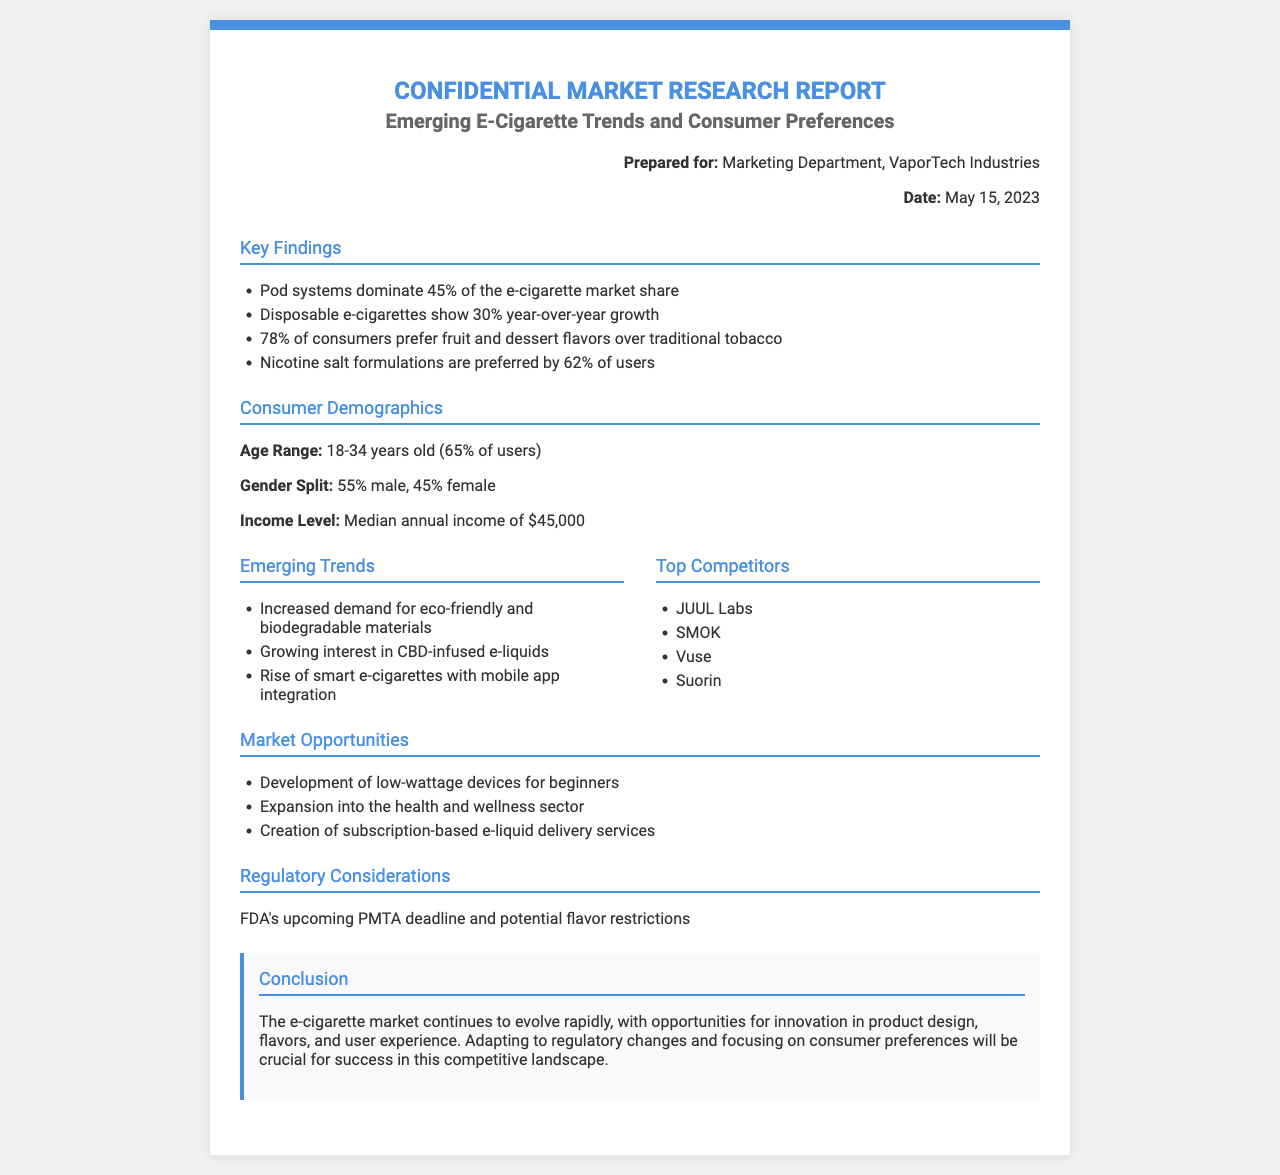What percentage of the e-cigarette market share do pod systems dominate? The document states that pod systems dominate 45% of the e-cigarette market share.
Answer: 45% What year-over-year growth percentage do disposable e-cigarettes show? The report mentions disposable e-cigarettes show 30% year-over-year growth.
Answer: 30% What flavor preference do 78% of consumers have? According to the findings, 78% of consumers prefer fruit and dessert flavors over traditional tobacco.
Answer: fruit and dessert flavors What age range constitutes 65% of e-cigarette users? The document specifies that the age range of 18-34 years old constitutes 65% of users.
Answer: 18-34 years old Which company is listed as a top competitor? The report lists JUUL Labs as one of the top competitors.
Answer: JUUL Labs What is a key market opportunity for the e-cigarette industry? One of the opportunities highlighted is the development of low-wattage devices for beginners.
Answer: low-wattage devices for beginners What demographic has a median annual income of $45,000? The consumer demographic mentioned in the document is the e-cigarette users with a median annual income of $45,000.
Answer: e-cigarette users What regulatory concern is highlighted in the report? The document notes the FDA's upcoming PMTA deadline and potential flavor restrictions as regulatory concerns.
Answer: FDA's upcoming PMTA deadline What is a trend concerning materials in the e-cigarette market? The report highlights increased demand for eco-friendly and biodegradable materials as an emerging trend.
Answer: eco-friendly and biodegradable materials 